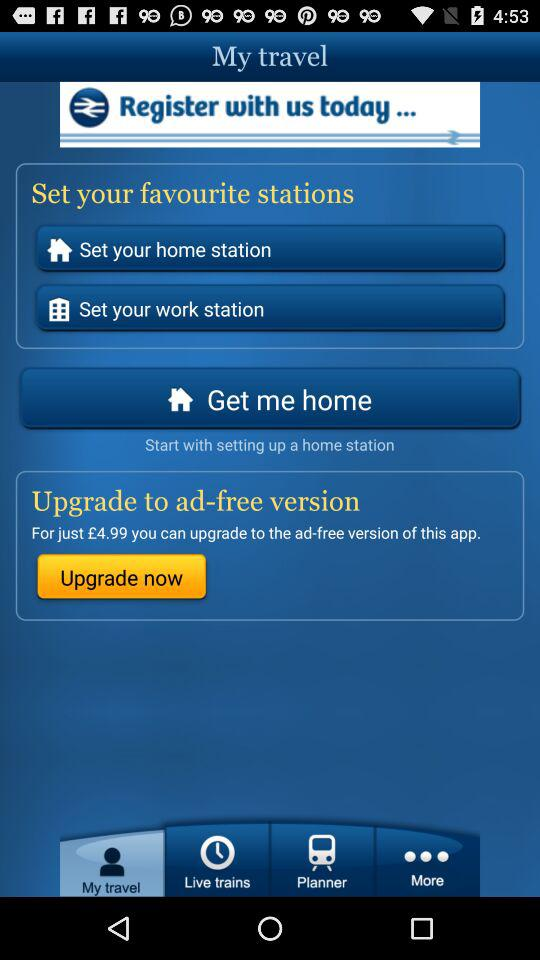Which tab is selected? The selected tab is "My travel". 